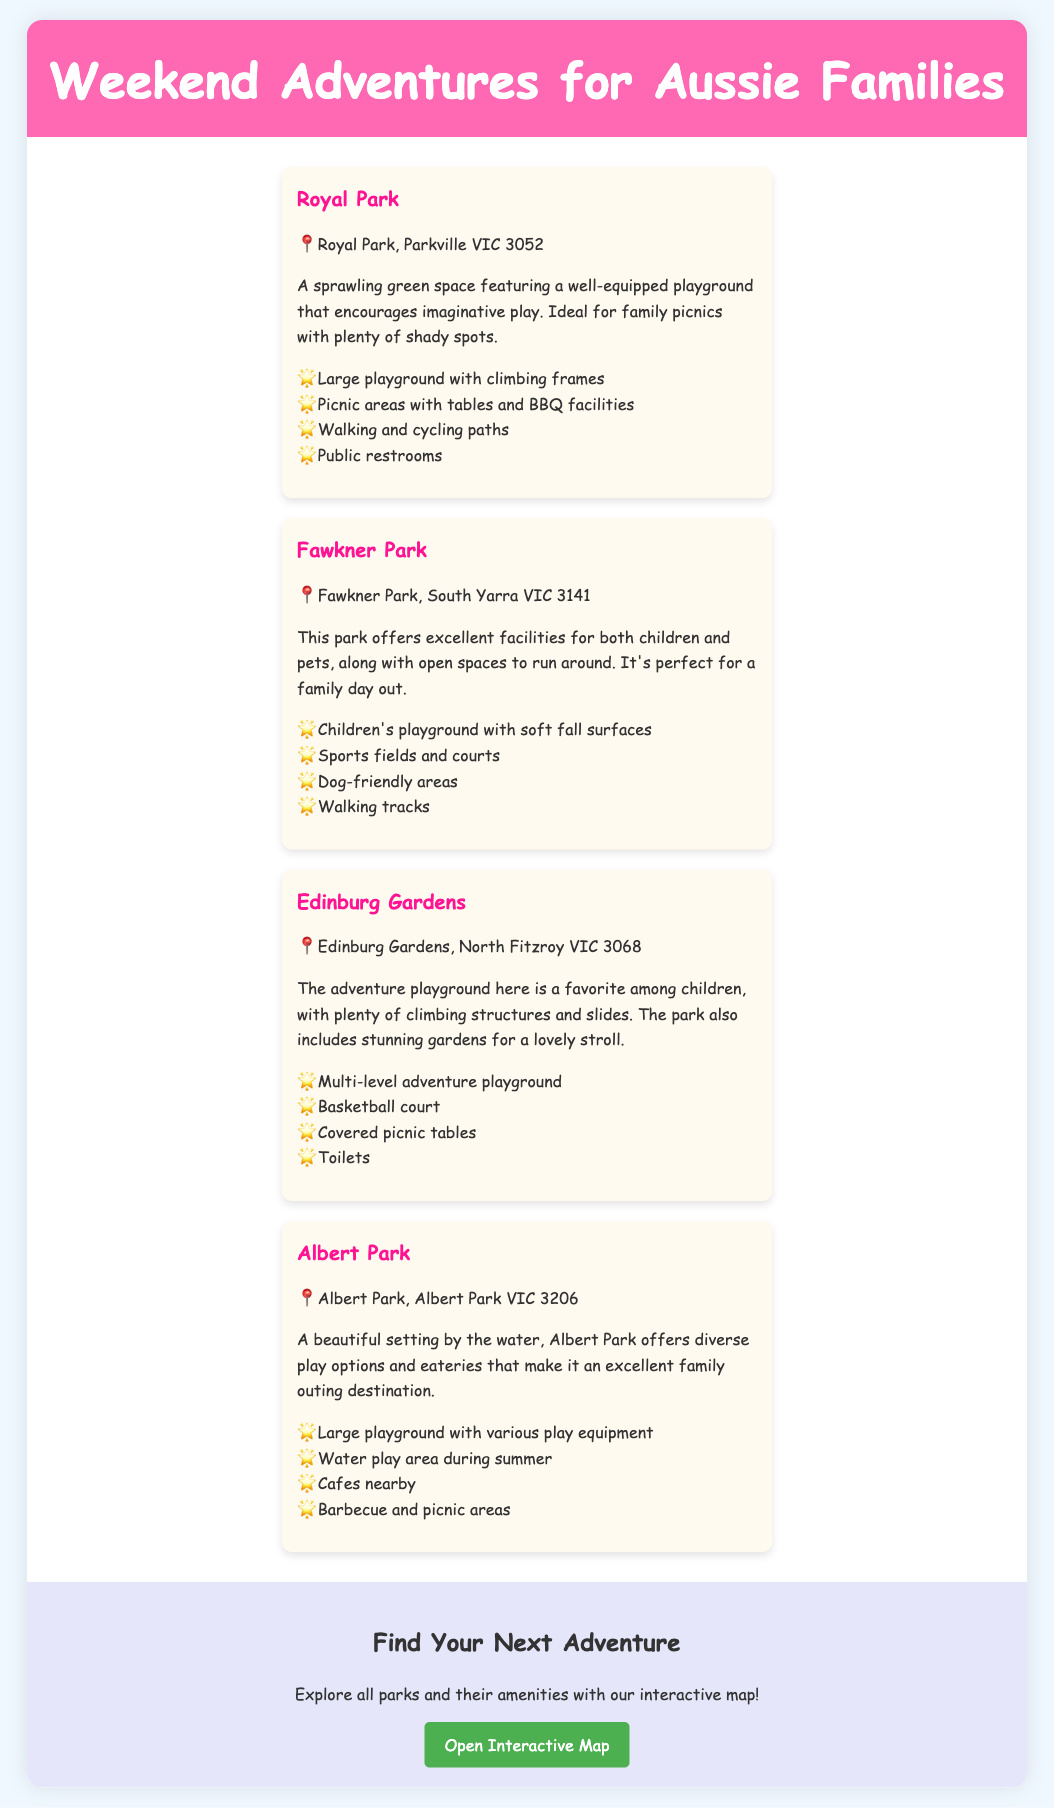what is the name of the first park listed? The first park in the document is listed as Royal Park.
Answer: Royal Park how many parks are mentioned in total? The document mentions a total of four parks.
Answer: 4 what type of playground is available at Fawkner Park? The playground at Fawkner Park is described as having soft fall surfaces.
Answer: soft fall surfaces which park has a water play area? The park that has a water play area during summer is Albert Park.
Answer: Albert Park what are the facilities available at Edinburg Gardens? The facilities at Edinburg Gardens include a multi-level adventure playground, basketball court, covered picnic tables, and toilets.
Answer: multi-level adventure playground, basketball court, covered picnic tables, toilets what is the common feature among all parks? All parks listed provide picnic areas or facilities for families.
Answer: picnic areas where can you find an interactive map of the parks? The interactive map can be found by clicking the link provided in the map section of the document.
Answer: interactive map link what is the unique feature of Royal Park? Royal Park features a well-equipped playground that encourages imaginative play.
Answer: well-equipped playground 